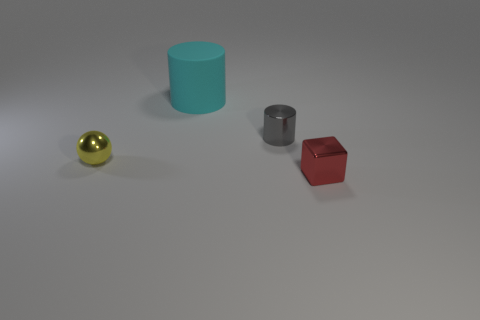If you had to guess, what material do you think each object is made from? Based on appearance, the sphere seems to be made of a polished metal or alloy, likely gold-colored, the blue and red objects seem like colored plastic, and the gray cylinder has a metallic sheen, suggesting it could be made of steel or aluminum. 